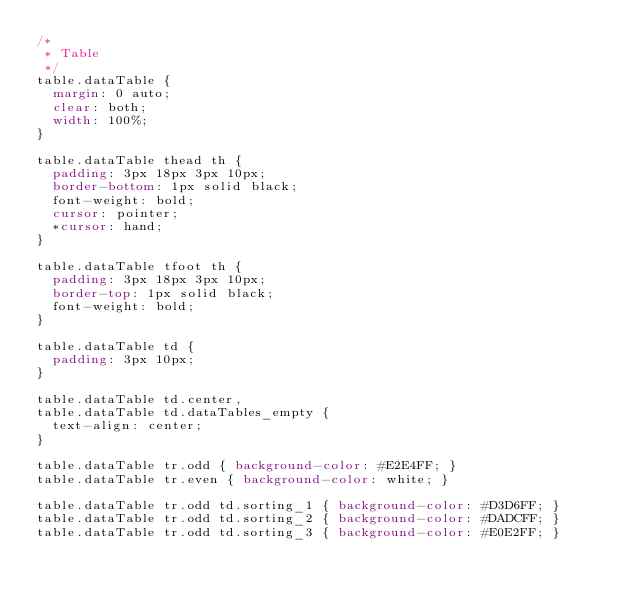<code> <loc_0><loc_0><loc_500><loc_500><_CSS_>/*
 * Table
 */
table.dataTable {
	margin: 0 auto;
	clear: both;
	width: 100%;
}

table.dataTable thead th {
	padding: 3px 18px 3px 10px;
	border-bottom: 1px solid black;
	font-weight: bold;
	cursor: pointer;
	*cursor: hand;
}

table.dataTable tfoot th {
	padding: 3px 18px 3px 10px;
	border-top: 1px solid black;
	font-weight: bold;
}

table.dataTable td {
	padding: 3px 10px;
}

table.dataTable td.center,
table.dataTable td.dataTables_empty {
	text-align: center;
}

table.dataTable tr.odd { background-color: #E2E4FF; }
table.dataTable tr.even { background-color: white; }

table.dataTable tr.odd td.sorting_1 { background-color: #D3D6FF; }
table.dataTable tr.odd td.sorting_2 { background-color: #DADCFF; }
table.dataTable tr.odd td.sorting_3 { background-color: #E0E2FF; }</code> 